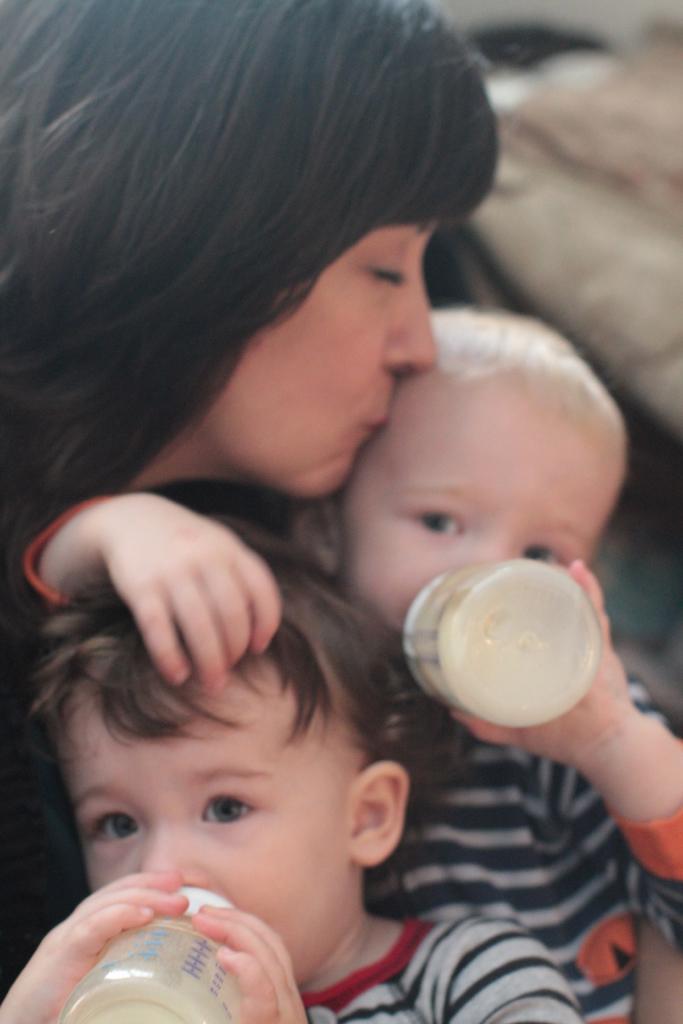How would you summarize this image in a sentence or two? In this picture there is a woman, kissing her child who is drinking a milk in the feeding bottle. There is another kid in front of him who is also drinking. 